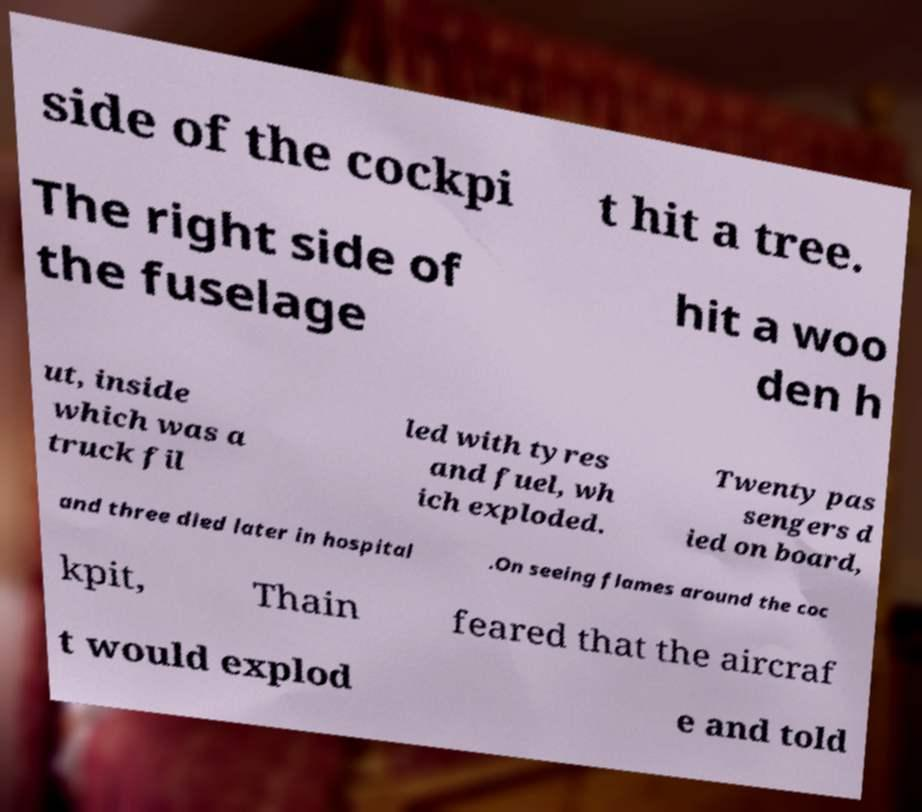Please identify and transcribe the text found in this image. side of the cockpi t hit a tree. The right side of the fuselage hit a woo den h ut, inside which was a truck fil led with tyres and fuel, wh ich exploded. Twenty pas sengers d ied on board, and three died later in hospital .On seeing flames around the coc kpit, Thain feared that the aircraf t would explod e and told 